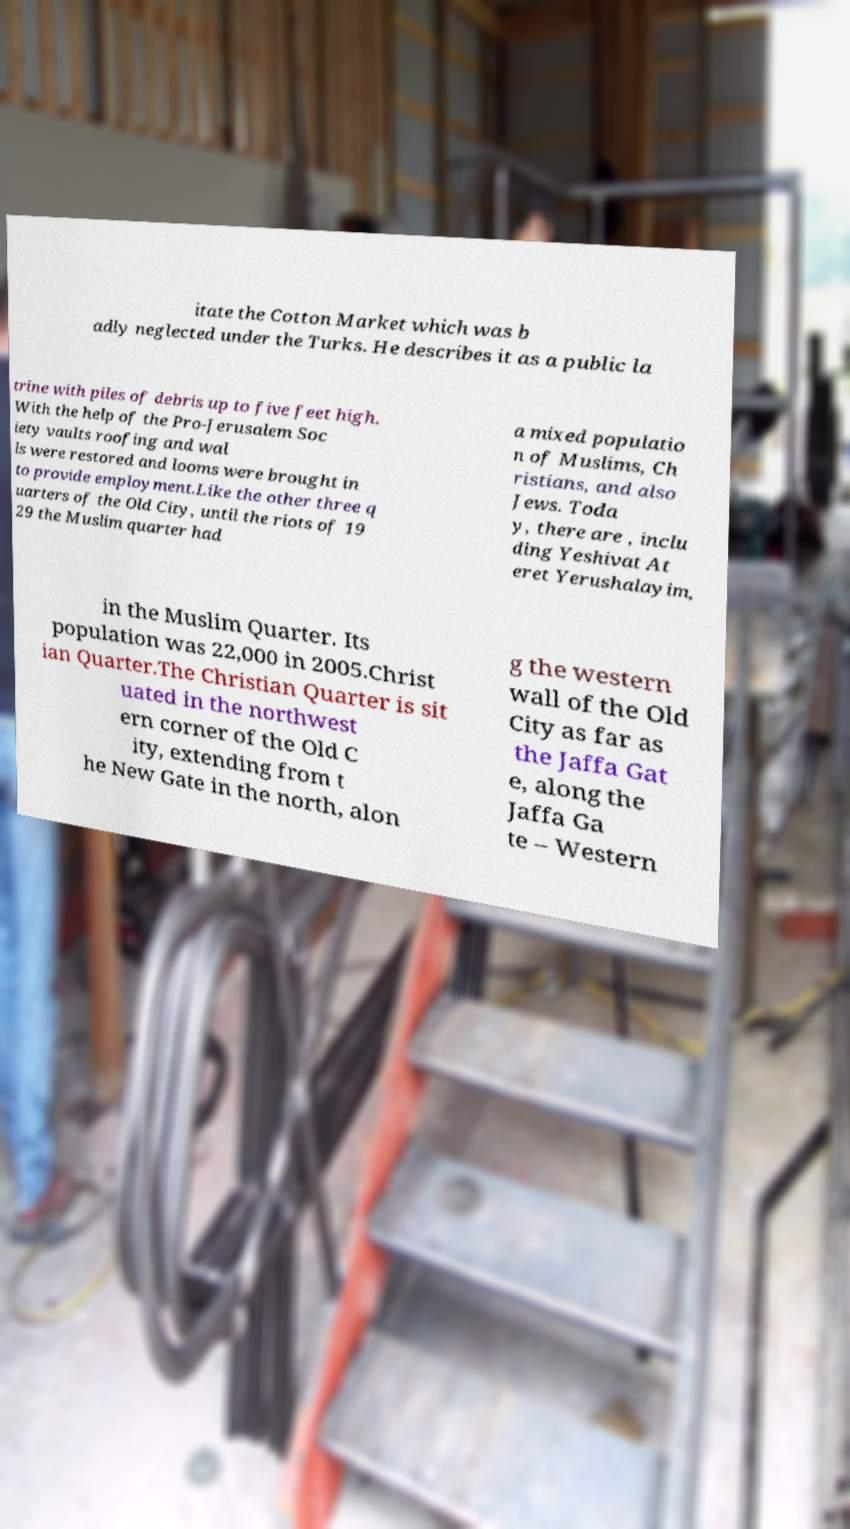Could you extract and type out the text from this image? itate the Cotton Market which was b adly neglected under the Turks. He describes it as a public la trine with piles of debris up to five feet high. With the help of the Pro-Jerusalem Soc iety vaults roofing and wal ls were restored and looms were brought in to provide employment.Like the other three q uarters of the Old City, until the riots of 19 29 the Muslim quarter had a mixed populatio n of Muslims, Ch ristians, and also Jews. Toda y, there are , inclu ding Yeshivat At eret Yerushalayim, in the Muslim Quarter. Its population was 22,000 in 2005.Christ ian Quarter.The Christian Quarter is sit uated in the northwest ern corner of the Old C ity, extending from t he New Gate in the north, alon g the western wall of the Old City as far as the Jaffa Gat e, along the Jaffa Ga te – Western 